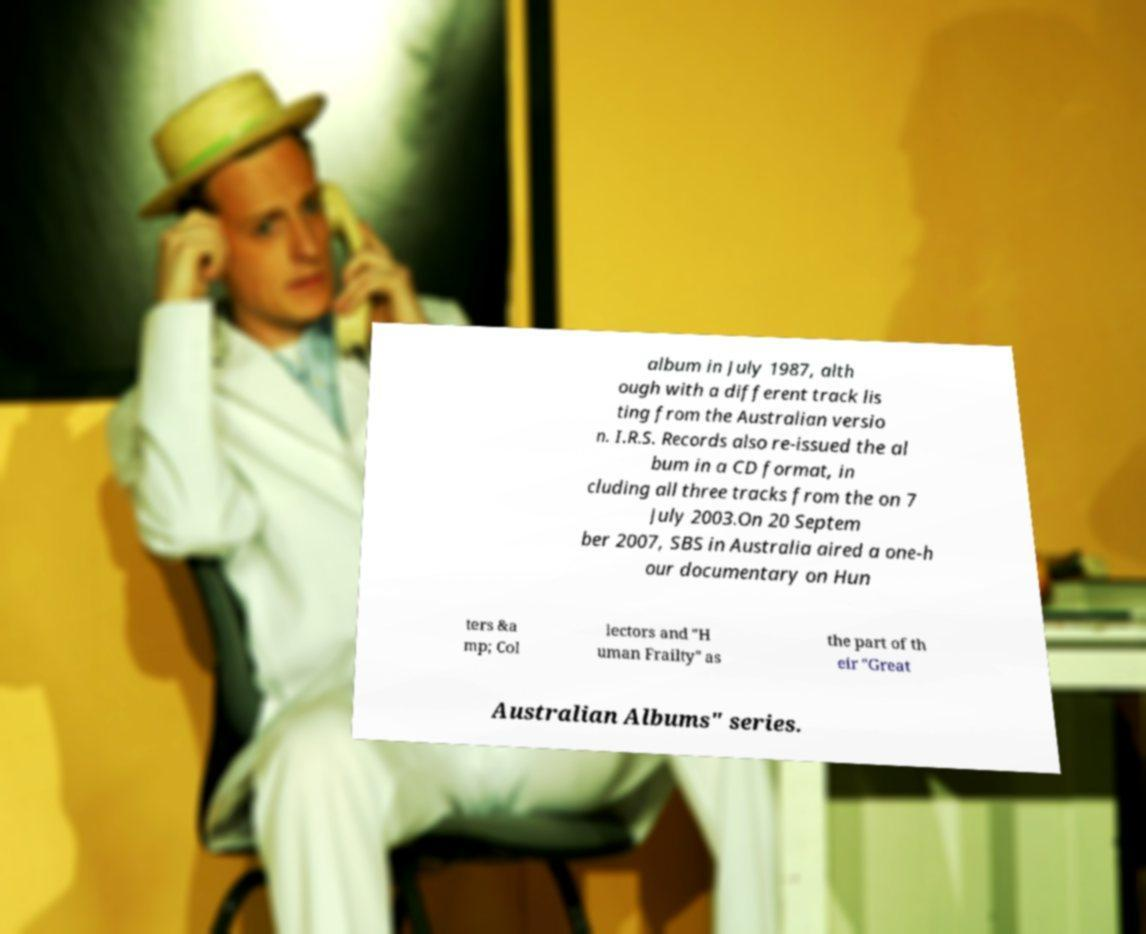Please identify and transcribe the text found in this image. album in July 1987, alth ough with a different track lis ting from the Australian versio n. I.R.S. Records also re-issued the al bum in a CD format, in cluding all three tracks from the on 7 July 2003.On 20 Septem ber 2007, SBS in Australia aired a one-h our documentary on Hun ters &a mp; Col lectors and "H uman Frailty" as the part of th eir "Great Australian Albums" series. 